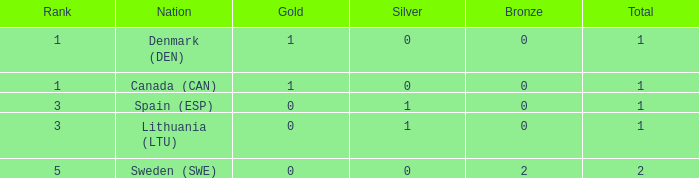What is the status when there is 0 gold, the aggregate is over 1, and silver is higher than 0? None. 